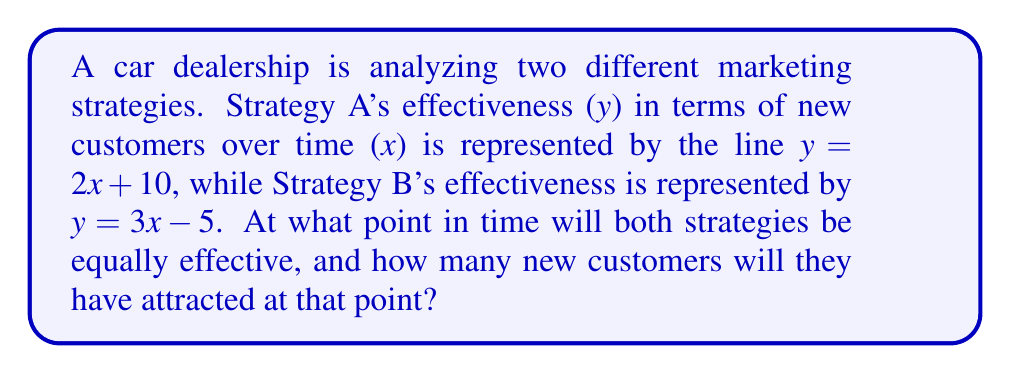Give your solution to this math problem. To solve this problem, we need to find the intersection point of the two lines representing the marketing strategies. This can be done using the following steps:

1. Set up the equation:
   Since we're looking for the point where both strategies are equally effective, we can set the equations equal to each other:
   $$2x + 10 = 3x - 5$$

2. Solve for x:
   $$2x + 10 = 3x - 5$$
   $$10 + 5 = 3x - 2x$$
   $$15 = x$$

3. Find y by substituting x into either equation:
   Let's use Strategy A's equation: $y = 2x + 10$
   $$y = 2(15) + 10$$
   $$y = 30 + 10 = 40$$

4. Interpret the results:
   The x-coordinate represents the time, and the y-coordinate represents the number of new customers.

[asy]
import graph;
size(200);
xaxis("Time (weeks)", arrow=Arrow);
yaxis("New Customers", arrow=Arrow);
real f(real x) {return 2x + 10;}
real g(real x) {return 3x - 5;}
draw(graph(f, 0, 20), blue, "Strategy A");
draw(graph(g, 0, 20), red, "Strategy B");
dot((15, 40));
label("(15, 40)", (15, 40), NE);
[/asy]
Answer: The two marketing strategies will be equally effective after 15 weeks, at which point they will have attracted 40 new customers. 